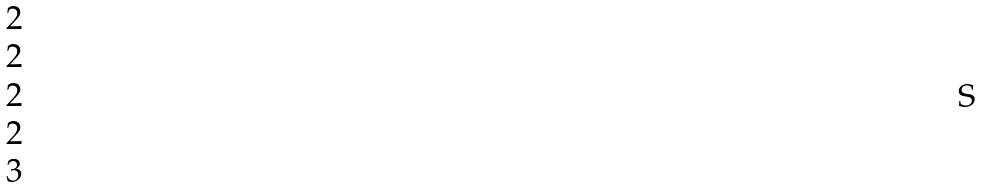<formula> <loc_0><loc_0><loc_500><loc_500>\begin{matrix} 2 \\ 2 \\ 2 \\ 2 \\ 3 \end{matrix}</formula> 